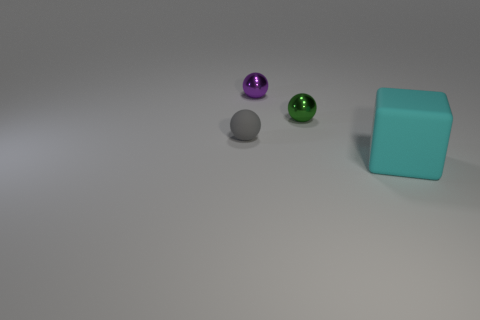Is there any other thing that is the same size as the block?
Provide a succinct answer. No. What number of things are small green spheres in front of the purple metal ball or matte things behind the big cyan rubber cube?
Make the answer very short. 2. What number of other small shiny objects are the same shape as the green shiny object?
Your answer should be compact. 1. There is a thing that is both in front of the tiny green ball and left of the rubber cube; what material is it?
Your response must be concise. Rubber. There is a tiny purple metallic thing; how many big cyan blocks are right of it?
Your answer should be very brief. 1. How many big blue spheres are there?
Offer a very short reply. 0. Do the purple thing and the cyan rubber object have the same size?
Provide a short and direct response. No. There is a object in front of the matte object on the left side of the cyan rubber cube; is there a small purple shiny ball to the right of it?
Offer a terse response. No. There is a tiny green object that is the same shape as the purple shiny thing; what is it made of?
Make the answer very short. Metal. What color is the rubber object that is on the left side of the large cyan object?
Provide a succinct answer. Gray. 